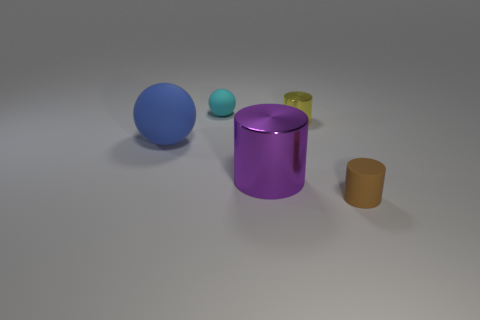There is a thing that is both behind the big blue object and in front of the small cyan matte object; what size is it?
Your answer should be very brief. Small. What number of things have the same material as the large blue sphere?
Provide a succinct answer. 2. What is the color of the tiny cylinder that is the same material as the tiny cyan object?
Your response must be concise. Brown. What material is the large object to the left of the large purple metal object?
Offer a very short reply. Rubber. Are there the same number of small yellow shiny cylinders that are in front of the blue matte ball and big green rubber cylinders?
Offer a very short reply. Yes. What number of small spheres are the same color as the large shiny cylinder?
Provide a succinct answer. 0. What color is the large matte object that is the same shape as the small cyan thing?
Provide a succinct answer. Blue. Is the cyan matte object the same size as the purple metal thing?
Keep it short and to the point. No. Is the number of yellow objects behind the blue thing the same as the number of tiny rubber objects to the left of the large metallic thing?
Your answer should be very brief. Yes. Are there any big gray things?
Provide a short and direct response. No. 